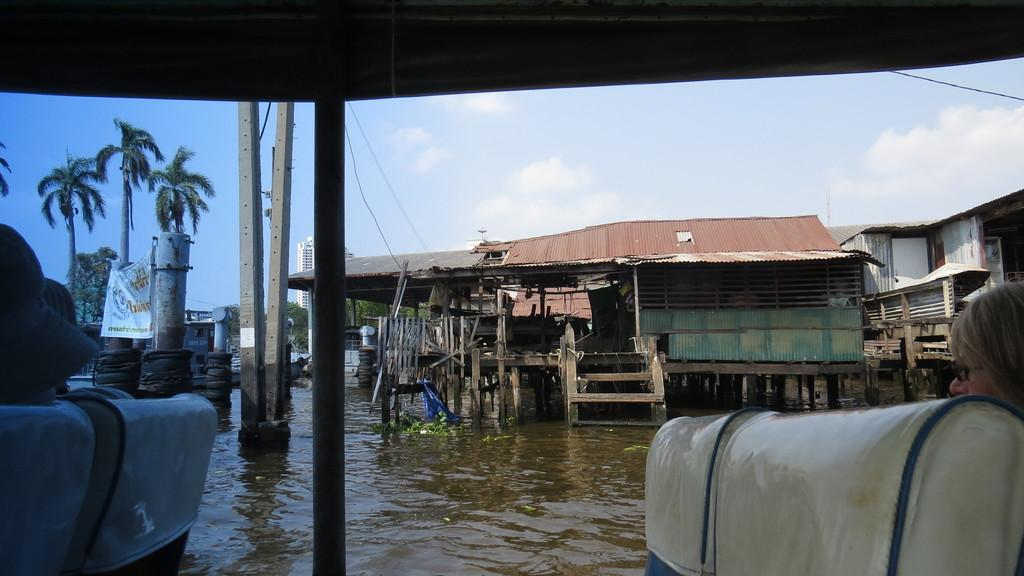What are the people in the image doing? The people in the image are sitting. What can be seen behind the people? There is water visible behind the people. What structures can be seen in the background of the image? There are houses, an electric pole, cables, a building, and trees in the background of the image. What part of the natural environment is visible in the image? The sky is visible in the background of the image. How many toes can be seen in the image? There are no visible toes in the image. 